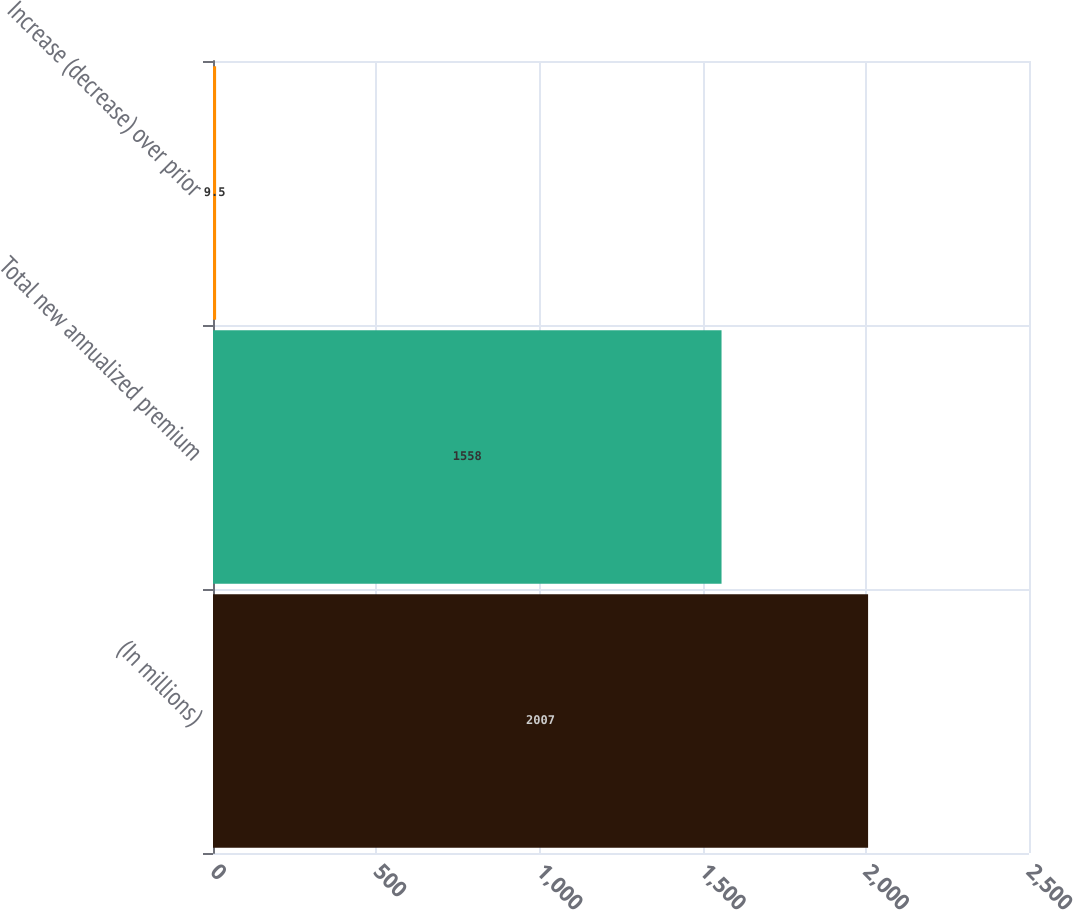Convert chart. <chart><loc_0><loc_0><loc_500><loc_500><bar_chart><fcel>(In millions)<fcel>Total new annualized premium<fcel>Increase (decrease) over prior<nl><fcel>2007<fcel>1558<fcel>9.5<nl></chart> 